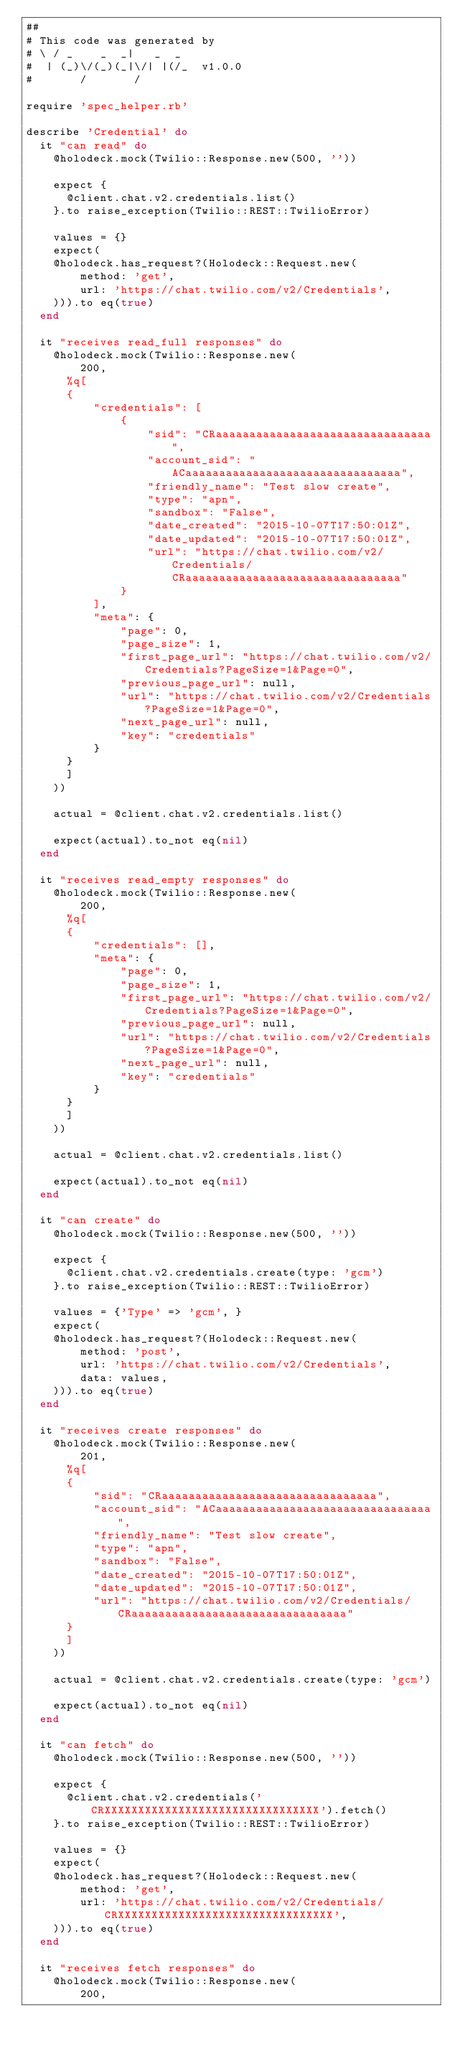Convert code to text. <code><loc_0><loc_0><loc_500><loc_500><_Ruby_>##
# This code was generated by
# \ / _    _  _|   _  _
#  | (_)\/(_)(_|\/| |(/_  v1.0.0
#       /       /

require 'spec_helper.rb'

describe 'Credential' do
  it "can read" do
    @holodeck.mock(Twilio::Response.new(500, ''))

    expect {
      @client.chat.v2.credentials.list()
    }.to raise_exception(Twilio::REST::TwilioError)

    values = {}
    expect(
    @holodeck.has_request?(Holodeck::Request.new(
        method: 'get',
        url: 'https://chat.twilio.com/v2/Credentials',
    ))).to eq(true)
  end

  it "receives read_full responses" do
    @holodeck.mock(Twilio::Response.new(
        200,
      %q[
      {
          "credentials": [
              {
                  "sid": "CRaaaaaaaaaaaaaaaaaaaaaaaaaaaaaaaa",
                  "account_sid": "ACaaaaaaaaaaaaaaaaaaaaaaaaaaaaaaaa",
                  "friendly_name": "Test slow create",
                  "type": "apn",
                  "sandbox": "False",
                  "date_created": "2015-10-07T17:50:01Z",
                  "date_updated": "2015-10-07T17:50:01Z",
                  "url": "https://chat.twilio.com/v2/Credentials/CRaaaaaaaaaaaaaaaaaaaaaaaaaaaaaaaa"
              }
          ],
          "meta": {
              "page": 0,
              "page_size": 1,
              "first_page_url": "https://chat.twilio.com/v2/Credentials?PageSize=1&Page=0",
              "previous_page_url": null,
              "url": "https://chat.twilio.com/v2/Credentials?PageSize=1&Page=0",
              "next_page_url": null,
              "key": "credentials"
          }
      }
      ]
    ))

    actual = @client.chat.v2.credentials.list()

    expect(actual).to_not eq(nil)
  end

  it "receives read_empty responses" do
    @holodeck.mock(Twilio::Response.new(
        200,
      %q[
      {
          "credentials": [],
          "meta": {
              "page": 0,
              "page_size": 1,
              "first_page_url": "https://chat.twilio.com/v2/Credentials?PageSize=1&Page=0",
              "previous_page_url": null,
              "url": "https://chat.twilio.com/v2/Credentials?PageSize=1&Page=0",
              "next_page_url": null,
              "key": "credentials"
          }
      }
      ]
    ))

    actual = @client.chat.v2.credentials.list()

    expect(actual).to_not eq(nil)
  end

  it "can create" do
    @holodeck.mock(Twilio::Response.new(500, ''))

    expect {
      @client.chat.v2.credentials.create(type: 'gcm')
    }.to raise_exception(Twilio::REST::TwilioError)

    values = {'Type' => 'gcm', }
    expect(
    @holodeck.has_request?(Holodeck::Request.new(
        method: 'post',
        url: 'https://chat.twilio.com/v2/Credentials',
        data: values,
    ))).to eq(true)
  end

  it "receives create responses" do
    @holodeck.mock(Twilio::Response.new(
        201,
      %q[
      {
          "sid": "CRaaaaaaaaaaaaaaaaaaaaaaaaaaaaaaaa",
          "account_sid": "ACaaaaaaaaaaaaaaaaaaaaaaaaaaaaaaaa",
          "friendly_name": "Test slow create",
          "type": "apn",
          "sandbox": "False",
          "date_created": "2015-10-07T17:50:01Z",
          "date_updated": "2015-10-07T17:50:01Z",
          "url": "https://chat.twilio.com/v2/Credentials/CRaaaaaaaaaaaaaaaaaaaaaaaaaaaaaaaa"
      }
      ]
    ))

    actual = @client.chat.v2.credentials.create(type: 'gcm')

    expect(actual).to_not eq(nil)
  end

  it "can fetch" do
    @holodeck.mock(Twilio::Response.new(500, ''))

    expect {
      @client.chat.v2.credentials('CRXXXXXXXXXXXXXXXXXXXXXXXXXXXXXXXX').fetch()
    }.to raise_exception(Twilio::REST::TwilioError)

    values = {}
    expect(
    @holodeck.has_request?(Holodeck::Request.new(
        method: 'get',
        url: 'https://chat.twilio.com/v2/Credentials/CRXXXXXXXXXXXXXXXXXXXXXXXXXXXXXXXX',
    ))).to eq(true)
  end

  it "receives fetch responses" do
    @holodeck.mock(Twilio::Response.new(
        200,</code> 